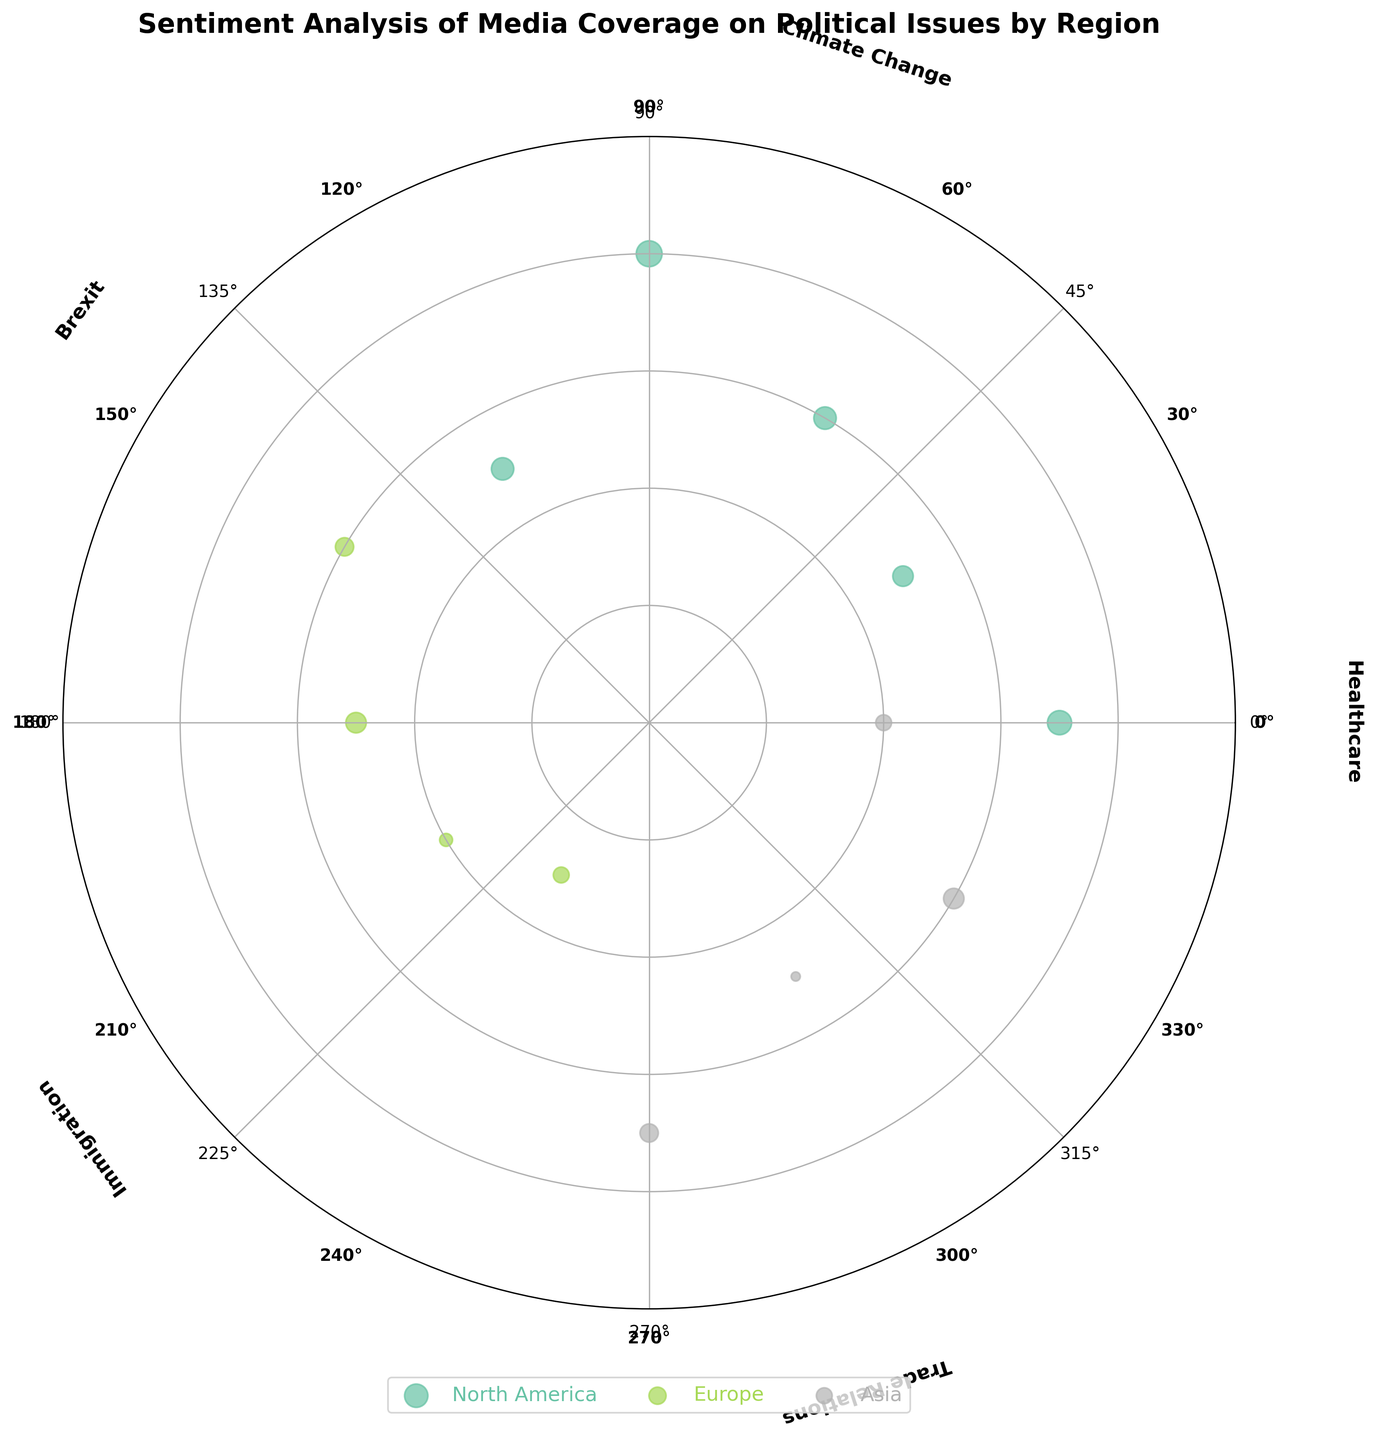What is the title of the figure? The title is typically displayed at the top of the figure. It summarizes the overall subject of the chart.
Answer: Sentiment Analysis of Media Coverage on Political Issues by Region What region has the most scattered points? To find the region with the most points, look for the region label in the legend with the most data points represented.
Answer: North America Which medium in North America has the most positive sentiment score for Climate Change? Identify the medium from the North America region that appears at the angle corresponding to Climate Change (90°). Compare their sentiment scores to find the highest.
Answer: CNN What is the color representing Europe? Check the legend for the color associated with Europe.
Answer: Light Green (depends on the actual color mapping in the Set2 colormap) Which region has a data point at the angle 270° and what is the sentiment score? Look for the data point located at 270° on the radial axis and identify the associated region and sentiment score.
Answer: Asia with sentiment score 0.4 How many political issues are represented in the figure? Count the unique values or labels around the outer circle of the polar scatter chart.
Answer: 5 Which political issue has the highest positive sentiment score and what is the medium? Examine all political issues' sentiment scores and identify the maximum positive value. Note the corresponding medium and issue.
Answer: Climate Change by CNN Compare the sentiment scores of Immigration covered by BBC and Deutsche Welle in Europe. Which one is higher? Locate the sentiment scores of Immigration for both mediums in Europe and compare them directly.
Answer: Deutsche Welle is higher (0.2 vs. -0.3) What is the relative position of BBC and The Guardian regarding Brexit sentiment in Europe, and what does it indicate? Identify the sentiment scores of BBC and The Guardian for Brexit. Position refers to their relative radial distance from the center.
Answer: The Guardian has a higher sentiment score (0.5) compared to BBC (-0.4), indicating The Guardian's coverage is more positive What are the political issues represented in the figure? Identify the textual labels placed around the outer circle of the chart that correspond to different angles.
Answer: Healthcare, Climate Change, Brexit, Immigration, Trade Relations 